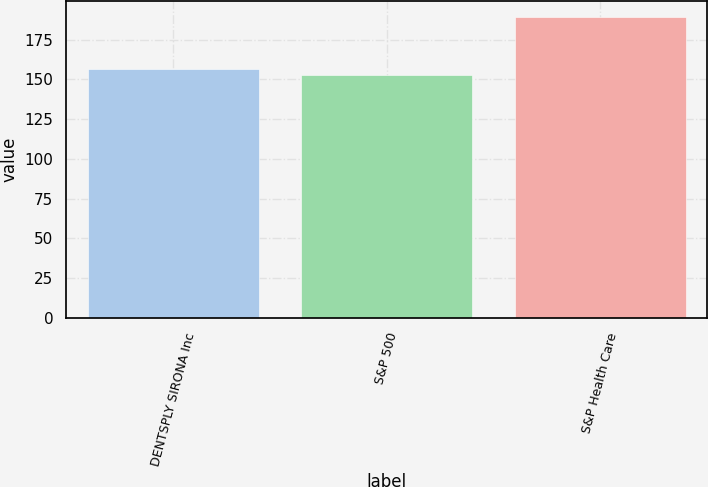Convert chart. <chart><loc_0><loc_0><loc_500><loc_500><bar_chart><fcel>DENTSPLY SIRONA Inc<fcel>S&P 500<fcel>S&P Health Care<nl><fcel>156.28<fcel>152.59<fcel>189.52<nl></chart> 